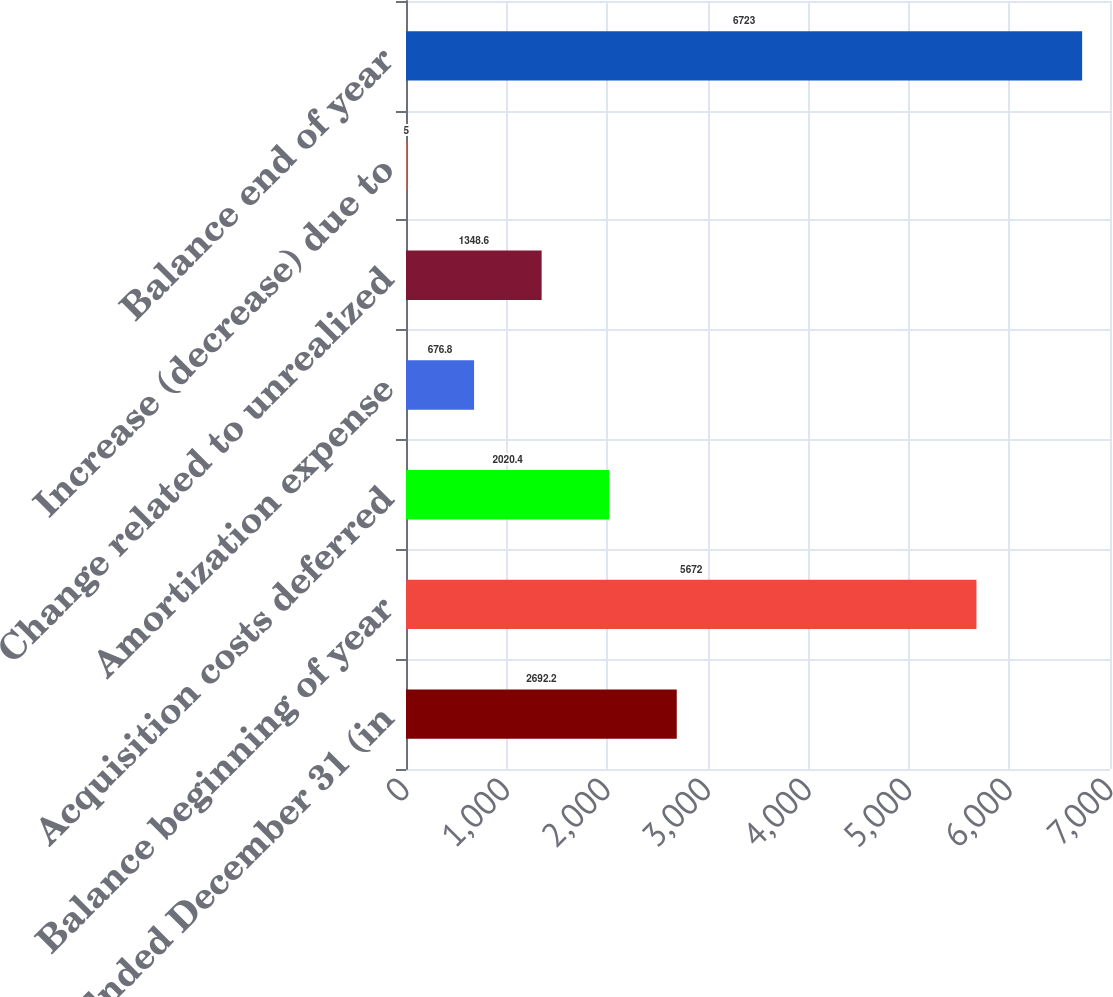Convert chart to OTSL. <chart><loc_0><loc_0><loc_500><loc_500><bar_chart><fcel>Years Ended December 31 (in<fcel>Balance beginning of year<fcel>Acquisition costs deferred<fcel>Amortization expense<fcel>Change related to unrealized<fcel>Increase (decrease) due to<fcel>Balance end of year<nl><fcel>2692.2<fcel>5672<fcel>2020.4<fcel>676.8<fcel>1348.6<fcel>5<fcel>6723<nl></chart> 